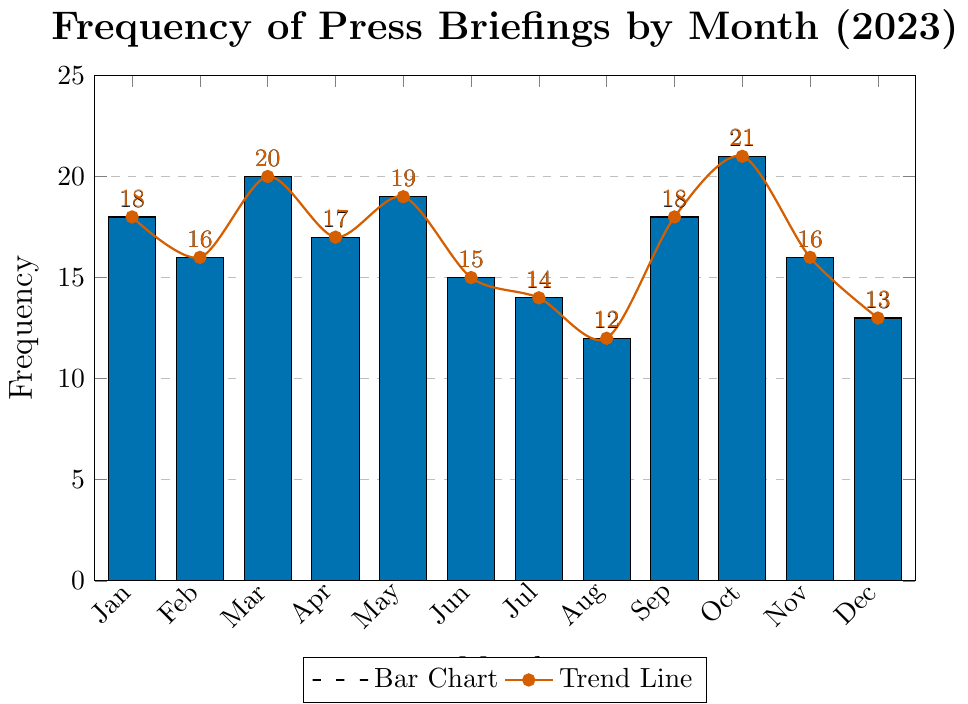What is the month with the highest frequency of press briefings? The bar for October reaches a height of 21, which is the highest among all months.
Answer: October What is the total frequency of press briefings for the first half of the year (Jan to Jun)? Sum the frequencies from January to June: 18 + 16 + 20 + 17 + 19 + 15 = 105.
Answer: 105 Which month had fewer press briefings, July or December? July had a frequency of 14, while December had a frequency of 13.
Answer: December How many more press briefings were there in March compared to August? The frequency in March is 20, and in August it is 12. The difference is 20 - 12 = 8.
Answer: 8 What is the average frequency of press briefings per month? Sum all frequencies and divide by 12 (the number of months): (18 + 16 + 20 + 17 + 19 + 15 + 14 + 12 + 18 + 21 + 16 + 13) / 12 = 199 / 12 ≈ 16.58.
Answer: 16.58 Is the frequency of press briefings in May higher or lower than the median frequency for the year? To find the median, first list the frequencies in ascending order: 12, 13, 14, 15, 16, 16, 17, 18, 18, 19, 20, 21. The median is the average of the 6th and 7th values: (16+17)/2 = 16.5. May has a frequency of 19, which is higher.
Answer: Higher What is the difference in frequency between the months with the highest and lowest numbers of press briefings? The highest frequency is in October (21), and the lowest is in August (12). The difference is 21 - 12 = 9.
Answer: 9 How does the frequency of press briefings in November compare to the average frequency for the year? November has 16 press briefings. The average for the year is approximately 16.58, so November's frequency is slightly below the average.
Answer: Slightly below Identify the visual representation indicating the trend line and its significance. The trend line is indicated by a smooth, thick, red line with circular markers, showing the overall trend of press briefings frequency throughout the year.
Answer: Red trend line 